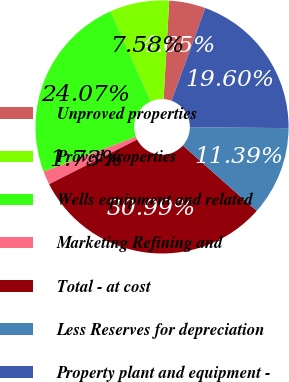Convert chart. <chart><loc_0><loc_0><loc_500><loc_500><pie_chart><fcel>Unproved properties<fcel>Proved properties<fcel>Wells equipment and related<fcel>Marketing Refining and<fcel>Total - at cost<fcel>Less Reserves for depreciation<fcel>Property plant and equipment -<nl><fcel>4.65%<fcel>7.58%<fcel>24.07%<fcel>1.73%<fcel>30.99%<fcel>11.39%<fcel>19.6%<nl></chart> 